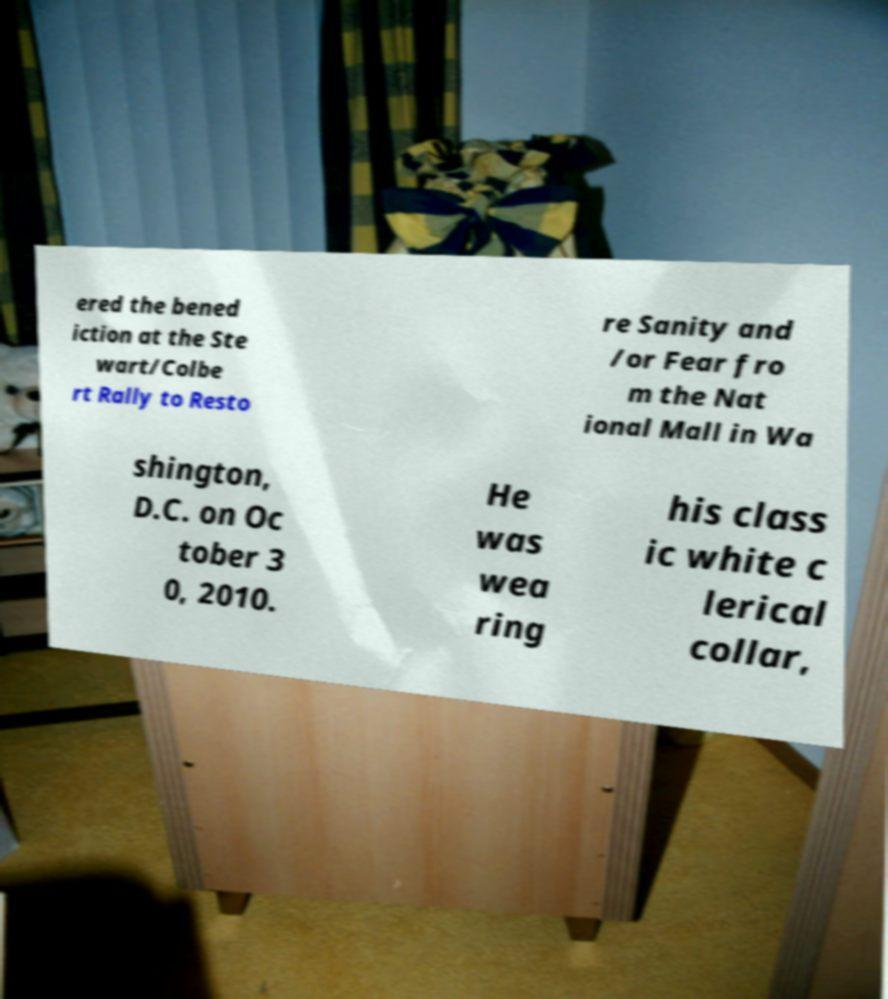Can you read and provide the text displayed in the image?This photo seems to have some interesting text. Can you extract and type it out for me? ered the bened iction at the Ste wart/Colbe rt Rally to Resto re Sanity and /or Fear fro m the Nat ional Mall in Wa shington, D.C. on Oc tober 3 0, 2010. He was wea ring his class ic white c lerical collar, 